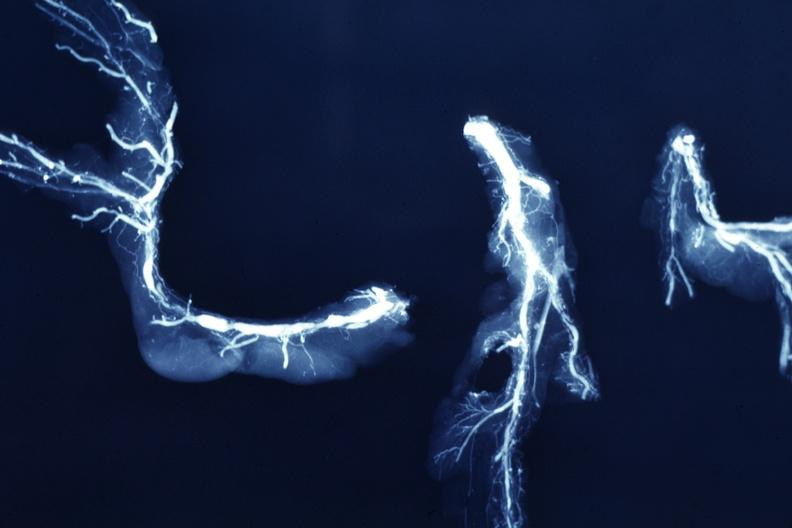where is this from?
Answer the question using a single word or phrase. Vasculature 